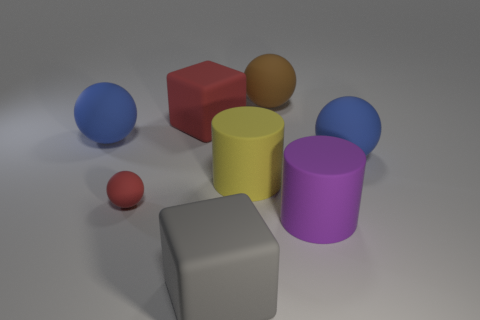Is there anything else that is the same size as the red matte ball?
Offer a very short reply. No. Is the shape of the thing that is in front of the purple cylinder the same as  the brown matte object?
Offer a very short reply. No. How many things are either big blue matte objects that are to the left of the large red cube or yellow objects?
Keep it short and to the point. 2. What is the shape of the yellow matte thing that is the same size as the gray object?
Offer a terse response. Cylinder. There is a blue sphere to the left of the small red rubber ball; does it have the same size as the matte block that is behind the large yellow thing?
Give a very brief answer. Yes. What is the color of the other block that is made of the same material as the big red block?
Your response must be concise. Gray. Are there any gray things that have the same size as the yellow rubber cylinder?
Keep it short and to the point. Yes. There is a red thing in front of the blue rubber thing that is left of the brown object; what size is it?
Provide a short and direct response. Small. How many big matte blocks are the same color as the tiny object?
Your response must be concise. 1. The big blue thing that is behind the blue rubber ball to the right of the big purple cylinder is what shape?
Ensure brevity in your answer.  Sphere. 